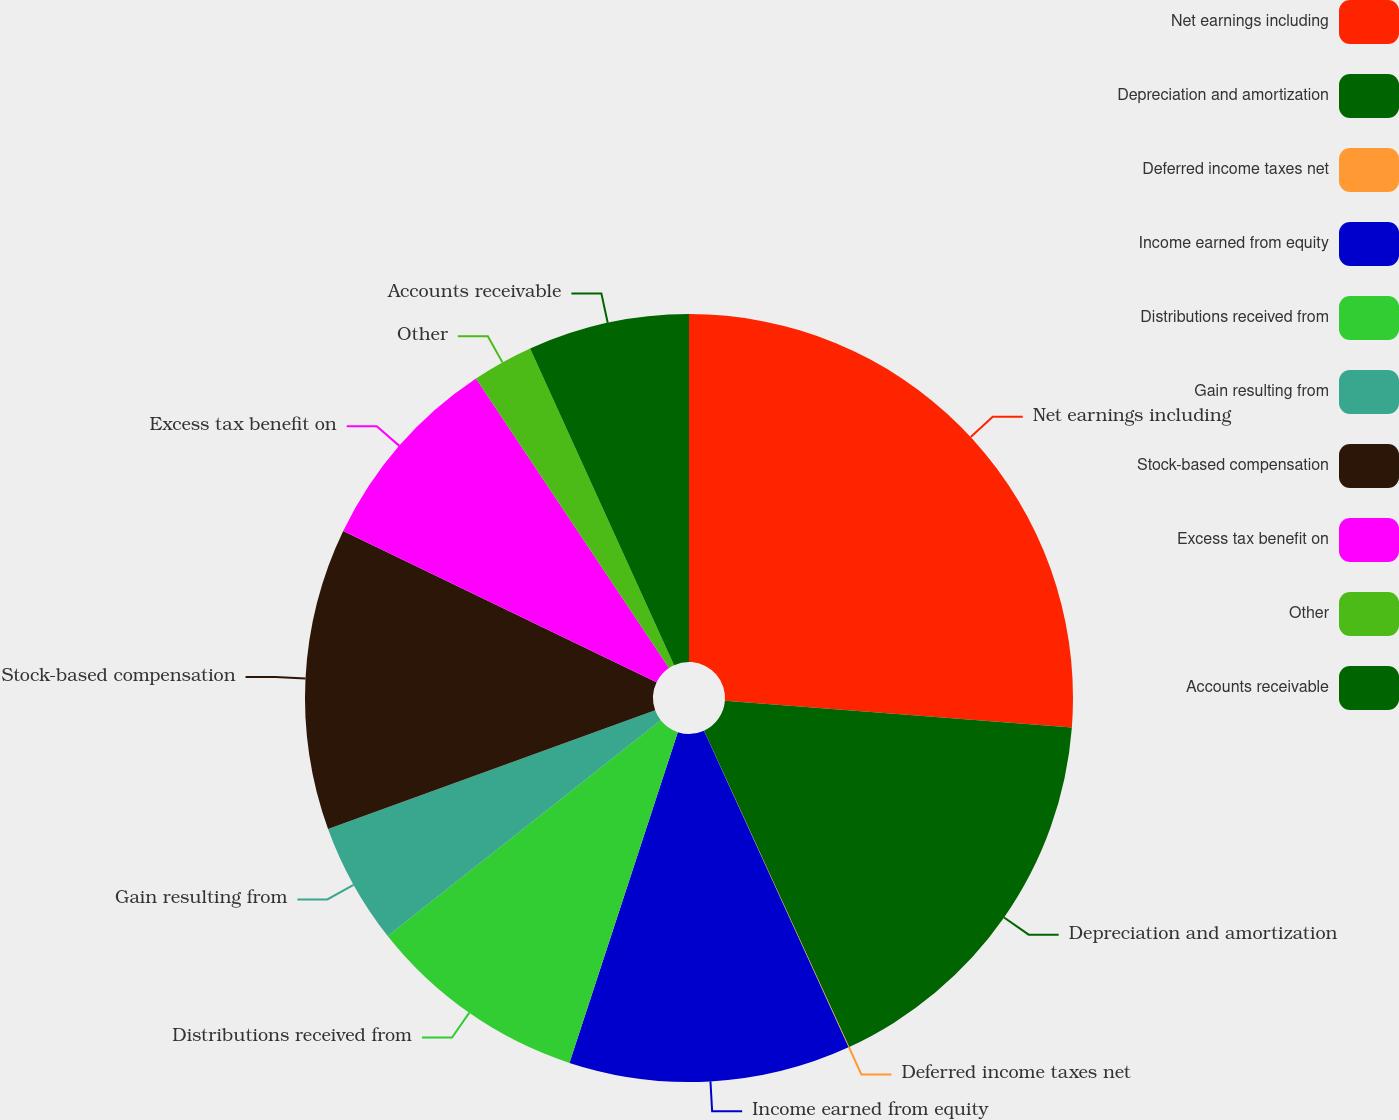Convert chart. <chart><loc_0><loc_0><loc_500><loc_500><pie_chart><fcel>Net earnings including<fcel>Depreciation and amortization<fcel>Deferred income taxes net<fcel>Income earned from equity<fcel>Distributions received from<fcel>Gain resulting from<fcel>Stock-based compensation<fcel>Excess tax benefit on<fcel>Other<fcel>Accounts receivable<nl><fcel>26.22%<fcel>16.93%<fcel>0.03%<fcel>11.86%<fcel>9.32%<fcel>5.1%<fcel>12.7%<fcel>8.48%<fcel>2.57%<fcel>6.79%<nl></chart> 